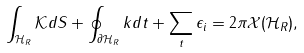Convert formula to latex. <formula><loc_0><loc_0><loc_500><loc_500>\int _ { \mathcal { H } _ { R } } \mathcal { K } d S + \oint _ { \partial \mathcal { H } _ { R } } k d t + \sum _ { t } \epsilon _ { i } = 2 \pi \mathcal { X } ( \mathcal { H } _ { R } ) ,</formula> 